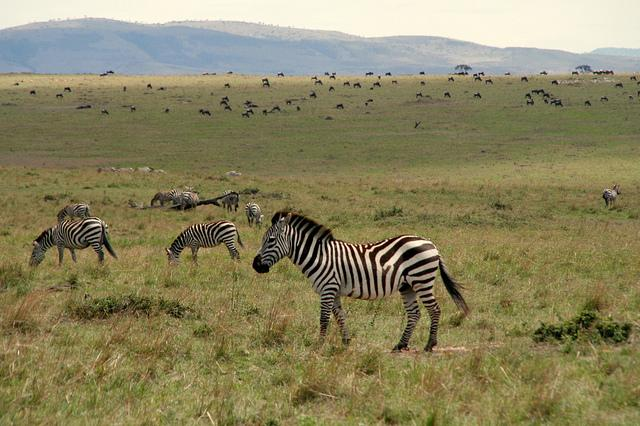What genus is this animal? Please explain your reasoning. equus. Zebras are included in the genus equus along with horses. 